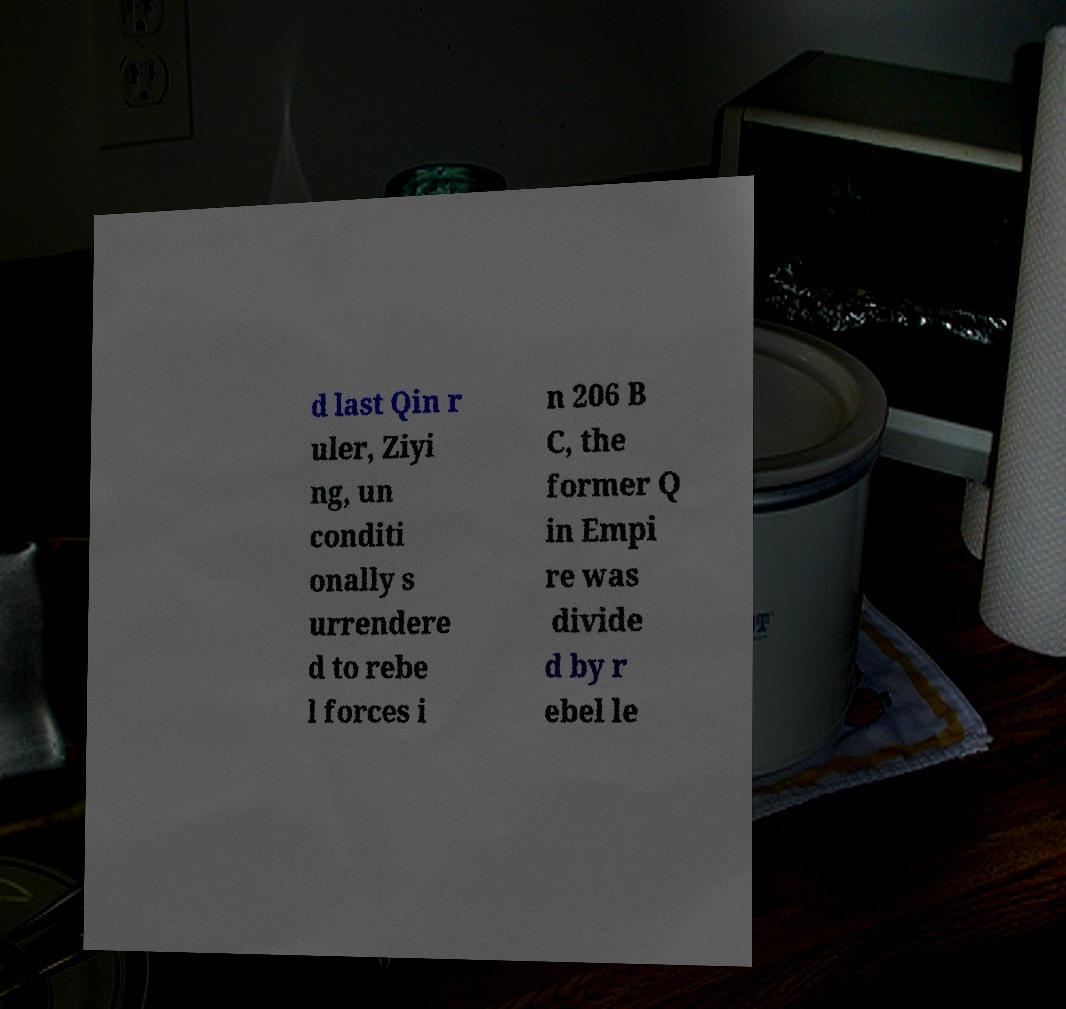Please identify and transcribe the text found in this image. d last Qin r uler, Ziyi ng, un conditi onally s urrendere d to rebe l forces i n 206 B C, the former Q in Empi re was divide d by r ebel le 